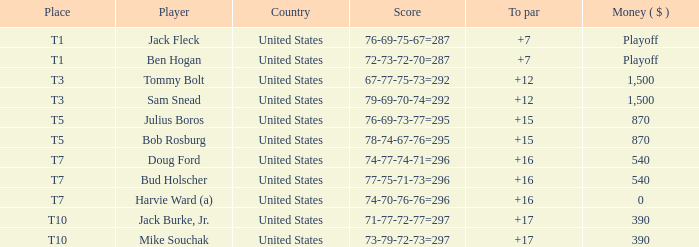What is the total of all to par with player Bob Rosburg? 15.0. 